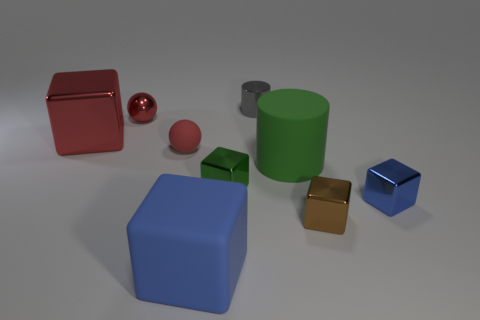Are there any other things that are the same size as the brown shiny object?
Provide a succinct answer. Yes. There is a big thing that is the same color as the matte ball; what material is it?
Keep it short and to the point. Metal. What size is the shiny sphere that is the same color as the large metallic block?
Keep it short and to the point. Small. Is there a cube that has the same color as the small shiny sphere?
Offer a terse response. Yes. Is the color of the large metallic cube the same as the sphere in front of the red block?
Offer a terse response. Yes. There is a big object that is the same color as the shiny ball; what shape is it?
Make the answer very short. Cube. There is a blue thing that is the same material as the tiny brown cube; what is its shape?
Your response must be concise. Cube. Are there fewer blue shiny things that are to the left of the green block than small blue matte objects?
Give a very brief answer. No. Is the number of big rubber objects that are right of the tiny green shiny thing greater than the number of red things in front of the tiny blue metal block?
Give a very brief answer. Yes. Is there any other thing of the same color as the metal cylinder?
Your answer should be compact. No. 